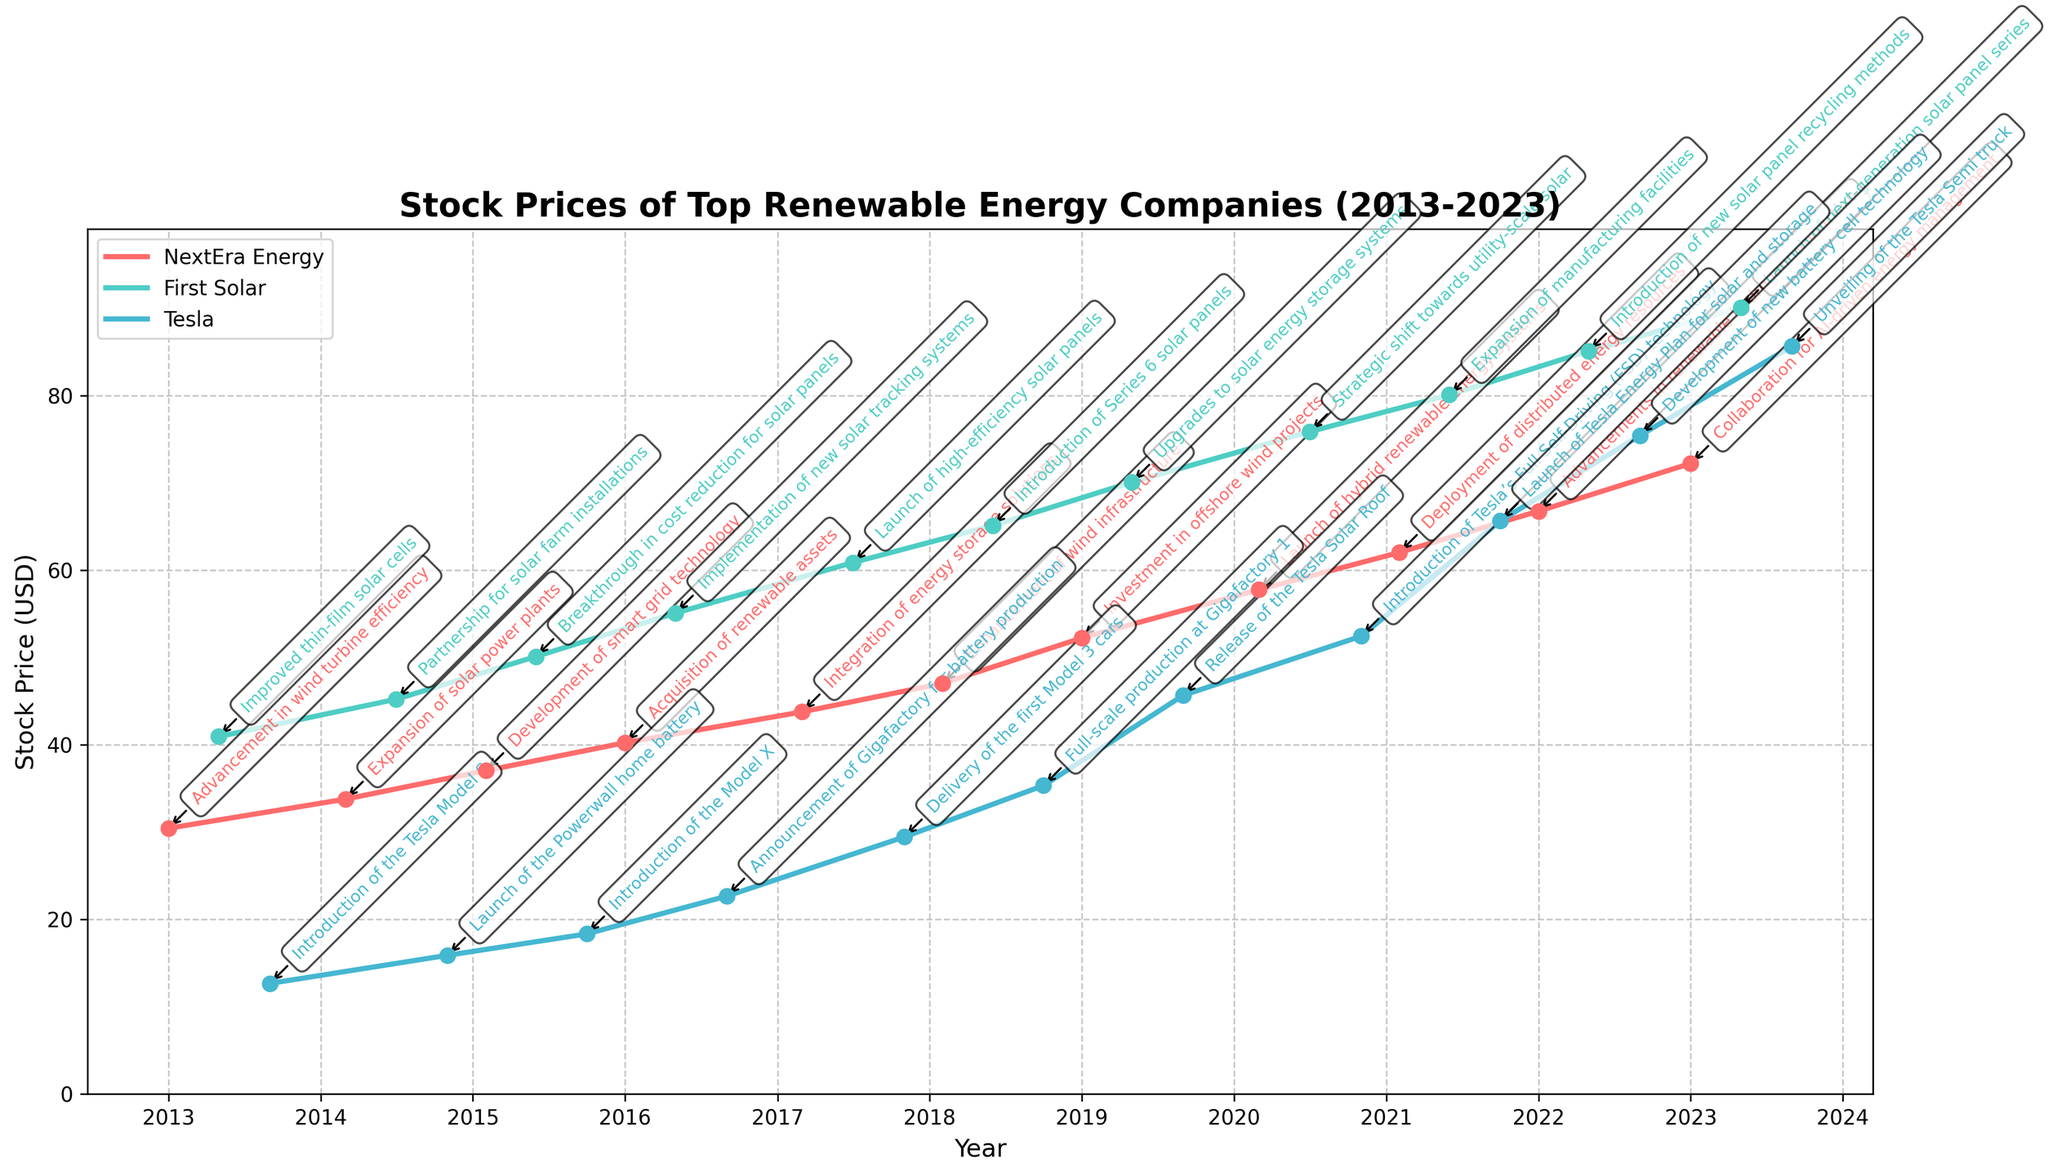What is the title of the plot? The title can be found at the top of the plot. It summarizes the overall purpose of the graph.
Answer: Stock Prices of Top Renewable Energy Companies (2013-2023) How are the stock prices of Tesla, First Solar, and NextEra Energy differentiated in the plot? The companies are indicated by different colors for their stock price lines and markers. Tesla is represented in orange, First Solar in teal, and NextEra Energy in blue.
Answer: By different colors What is the stock price of Tesla in September 2023? Locate the point for Tesla in September 2023 on the plot and read the corresponding stock price value.
Answer: 85.67 USD How does the stock price of NextEra Energy in January 2016 compare to that in January 2023? Find the stock prices of NextEra Energy in January 2016 and January 2023 from the plot, then compare these two values.
Answer: 40.25 USD in 2016, 72.25 USD in 2023 Which company had the highest stock price in January 2021? Identify the stock prices for all companies in January 2021 and determine which one is the highest.
Answer: First Solar How did the stock price of First Solar change from June 2018 to February 2021? Find the stock prices for First Solar in June 2018 and February 2021, then calculate the difference.
Answer: Increased from 65.12 USD to 80.10 USD What major innovation was introduced by Tesla in 2019, and how did it affect its stock price? Check the annotation for Tesla in 2019 to find the major innovation and observe the trend in stock prices before and after the innovation.
Answer: Release of the Tesla Solar Roof; the stock price increased Did NextEra Energy's stock price ever drop below 30 USD in the observed period? Look through the entire plot for NextEra Energy to see if any data points are below 30 USD.
Answer: No What technological advancement coincided with the highest stock price for First Solar? Find the highest stock price of First Solar and check the corresponding annotation for the technological advancement.
Answer: Next-generation solar panel series By how much did the stock price for Tesla increase from the introduction of the Gigafactory for battery production to the launch of Tesla’s Full Self-Driving technology? Locate stock prices for the two events in September 2016 and November 2020, and calculate the difference.
Answer: Increased from 22.67 USD to 52.45 USD 